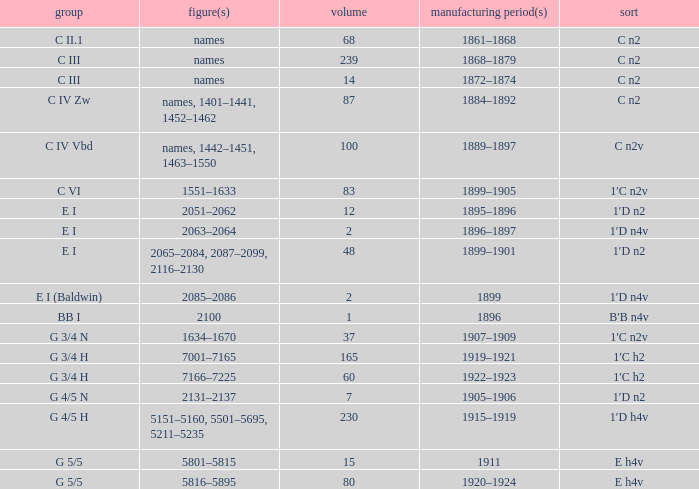Which Quantity has a Type of e h4v, and a Year(s) of Manufacture of 1920–1924? 80.0. 